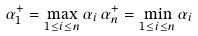Convert formula to latex. <formula><loc_0><loc_0><loc_500><loc_500>\alpha _ { 1 } ^ { + } = \max _ { 1 \leq i \leq n } \alpha _ { i } \, \alpha _ { n } ^ { + } = \min _ { 1 \leq i \leq n } \alpha _ { i }</formula> 